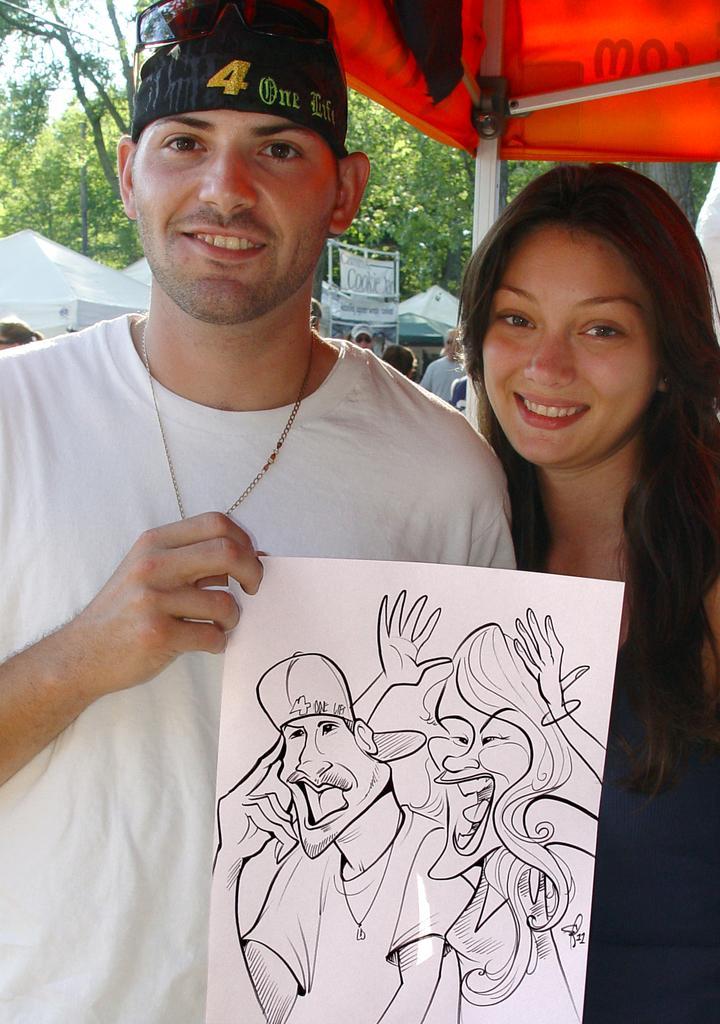Please provide a concise description of this image. In this image we can see two persons standing. One person wearing white t shirt, cap is holding a paper with a drawing in his hand. In the background, we can see a group of sheds, a group of people, banner with some text, a group of trees and the sky. 